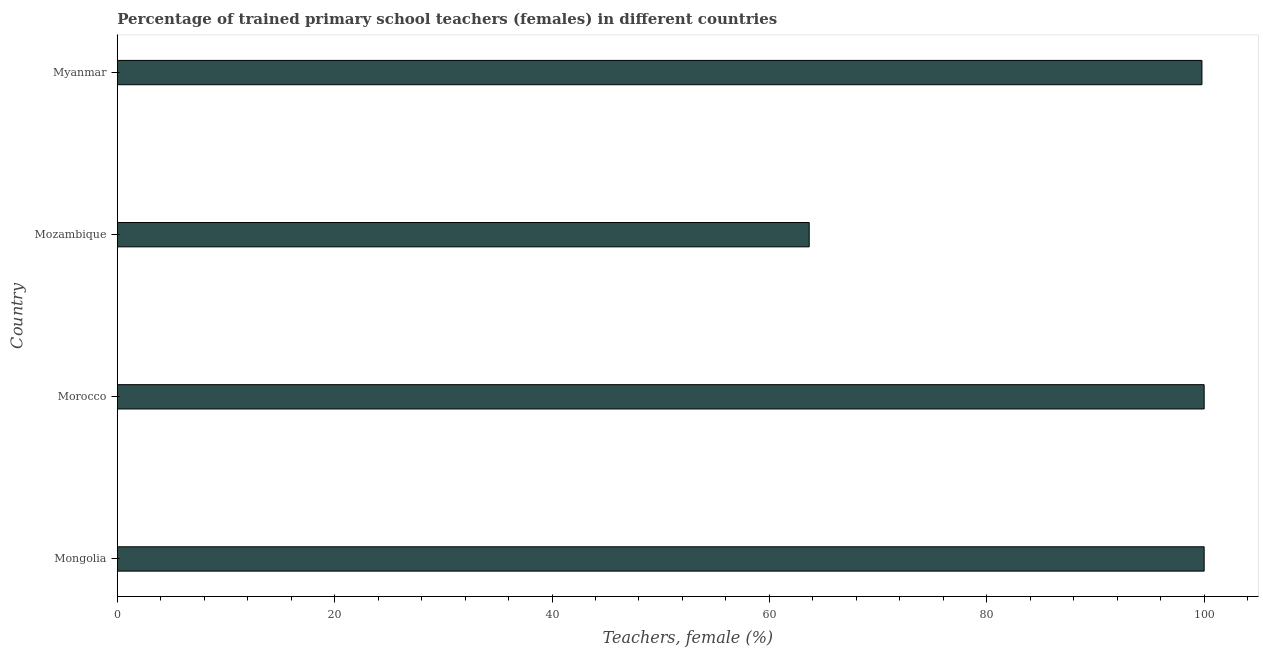What is the title of the graph?
Provide a succinct answer. Percentage of trained primary school teachers (females) in different countries. What is the label or title of the X-axis?
Offer a very short reply. Teachers, female (%). What is the label or title of the Y-axis?
Offer a terse response. Country. What is the percentage of trained female teachers in Morocco?
Offer a very short reply. 100. Across all countries, what is the minimum percentage of trained female teachers?
Your answer should be very brief. 63.66. In which country was the percentage of trained female teachers maximum?
Offer a very short reply. Mongolia. In which country was the percentage of trained female teachers minimum?
Provide a succinct answer. Mozambique. What is the sum of the percentage of trained female teachers?
Your answer should be compact. 363.46. What is the difference between the percentage of trained female teachers in Mongolia and Morocco?
Offer a very short reply. 0. What is the average percentage of trained female teachers per country?
Provide a short and direct response. 90.86. What is the median percentage of trained female teachers?
Keep it short and to the point. 99.9. In how many countries, is the percentage of trained female teachers greater than 12 %?
Offer a very short reply. 4. What is the ratio of the percentage of trained female teachers in Mongolia to that in Myanmar?
Ensure brevity in your answer.  1. What is the difference between the highest and the second highest percentage of trained female teachers?
Keep it short and to the point. 0. What is the difference between the highest and the lowest percentage of trained female teachers?
Your answer should be compact. 36.34. Are all the bars in the graph horizontal?
Offer a very short reply. Yes. Are the values on the major ticks of X-axis written in scientific E-notation?
Provide a succinct answer. No. What is the Teachers, female (%) in Mongolia?
Your response must be concise. 100. What is the Teachers, female (%) of Mozambique?
Your answer should be very brief. 63.66. What is the Teachers, female (%) in Myanmar?
Keep it short and to the point. 99.8. What is the difference between the Teachers, female (%) in Mongolia and Mozambique?
Your answer should be very brief. 36.34. What is the difference between the Teachers, female (%) in Mongolia and Myanmar?
Your answer should be very brief. 0.2. What is the difference between the Teachers, female (%) in Morocco and Mozambique?
Your response must be concise. 36.34. What is the difference between the Teachers, female (%) in Morocco and Myanmar?
Offer a very short reply. 0.2. What is the difference between the Teachers, female (%) in Mozambique and Myanmar?
Give a very brief answer. -36.13. What is the ratio of the Teachers, female (%) in Mongolia to that in Mozambique?
Ensure brevity in your answer.  1.57. What is the ratio of the Teachers, female (%) in Mongolia to that in Myanmar?
Your answer should be compact. 1. What is the ratio of the Teachers, female (%) in Morocco to that in Mozambique?
Offer a very short reply. 1.57. What is the ratio of the Teachers, female (%) in Morocco to that in Myanmar?
Make the answer very short. 1. What is the ratio of the Teachers, female (%) in Mozambique to that in Myanmar?
Keep it short and to the point. 0.64. 